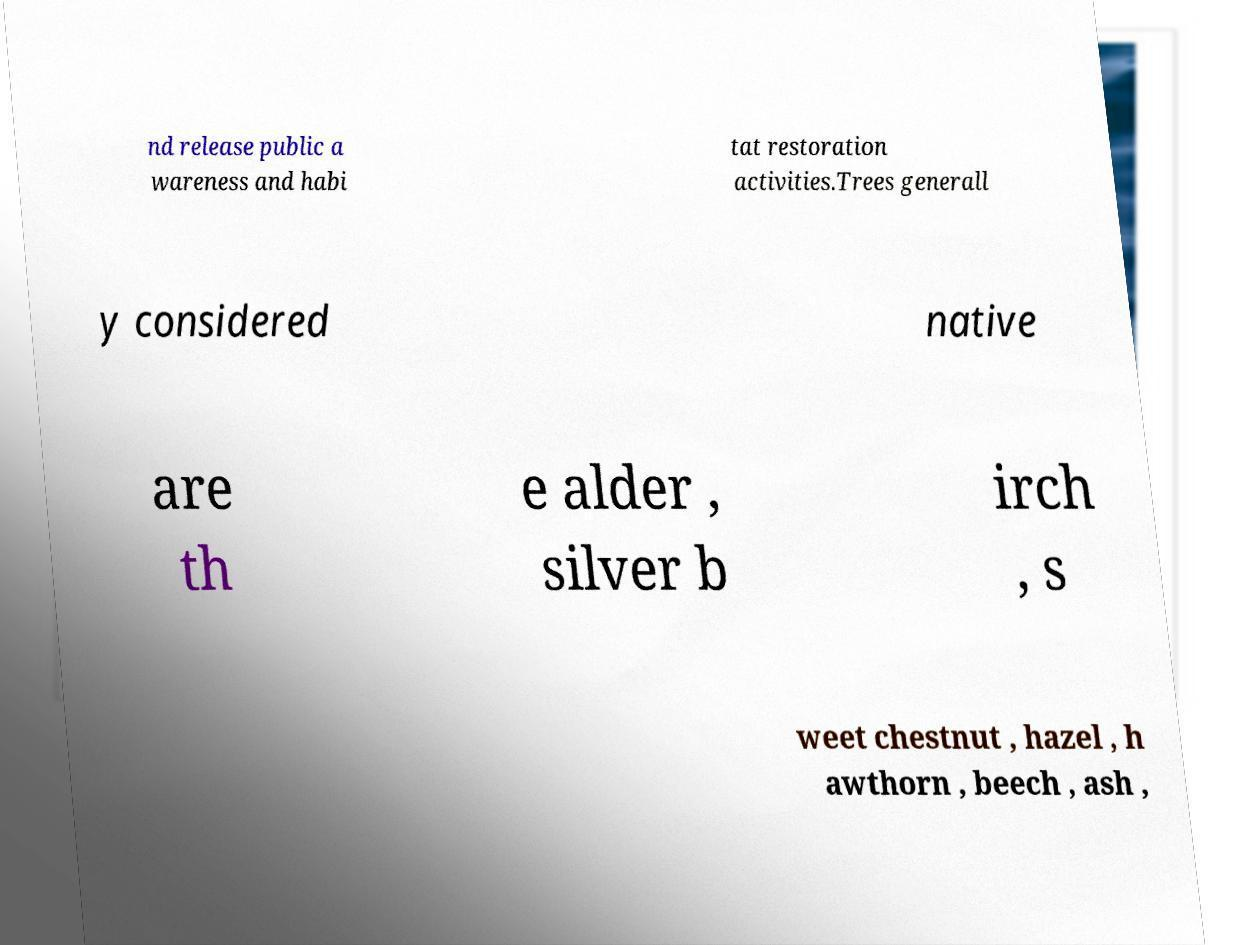For documentation purposes, I need the text within this image transcribed. Could you provide that? nd release public a wareness and habi tat restoration activities.Trees generall y considered native are th e alder , silver b irch , s weet chestnut , hazel , h awthorn , beech , ash , 